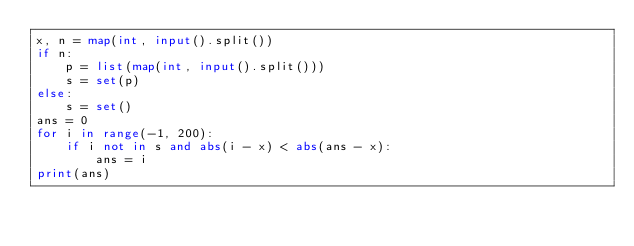Convert code to text. <code><loc_0><loc_0><loc_500><loc_500><_Python_>x, n = map(int, input().split())
if n:
    p = list(map(int, input().split()))
    s = set(p)
else:
    s = set()
ans = 0
for i in range(-1, 200):
    if i not in s and abs(i - x) < abs(ans - x):
        ans = i
print(ans)</code> 